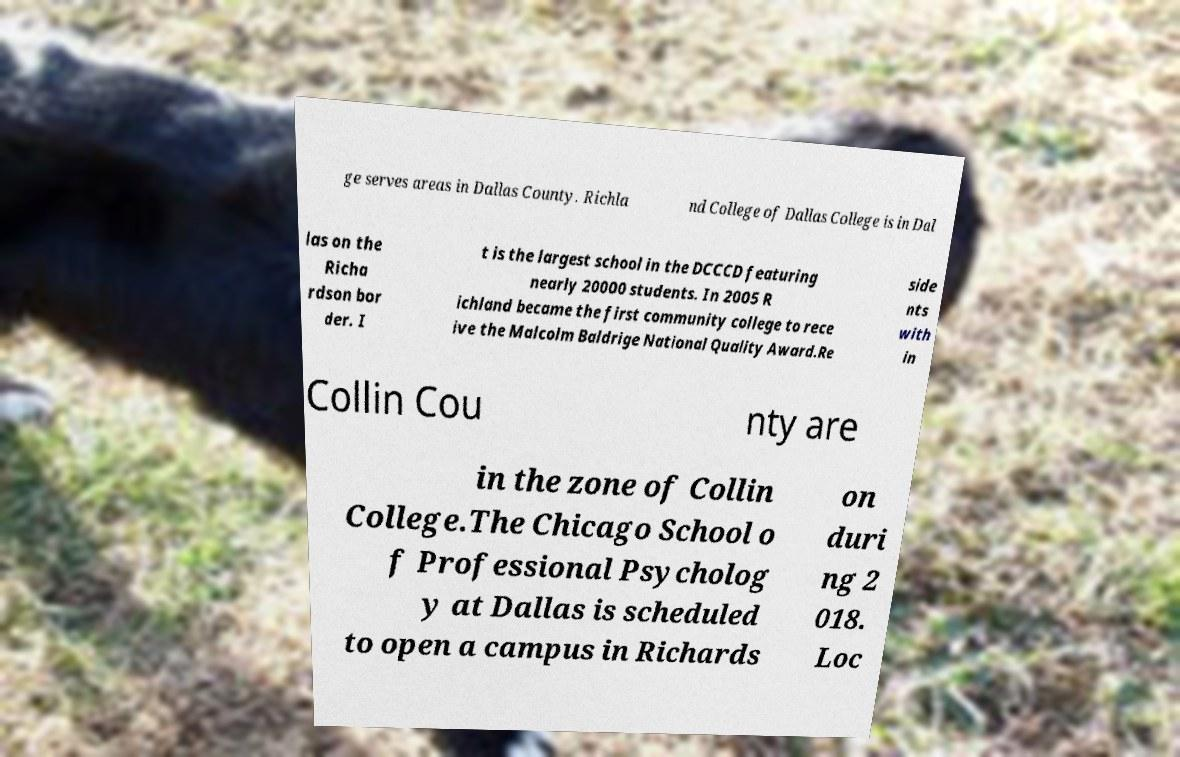Please identify and transcribe the text found in this image. ge serves areas in Dallas County. Richla nd College of Dallas College is in Dal las on the Richa rdson bor der. I t is the largest school in the DCCCD featuring nearly 20000 students. In 2005 R ichland became the first community college to rece ive the Malcolm Baldrige National Quality Award.Re side nts with in Collin Cou nty are in the zone of Collin College.The Chicago School o f Professional Psycholog y at Dallas is scheduled to open a campus in Richards on duri ng 2 018. Loc 